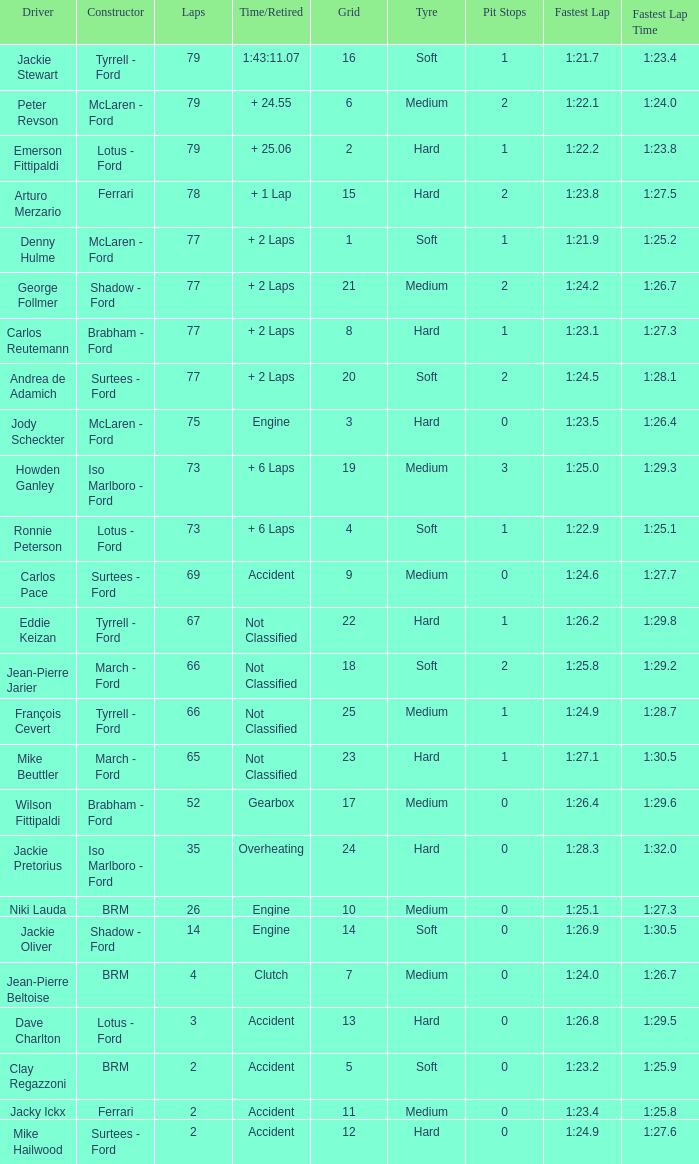What is the total grid with laps less than 2? None. 